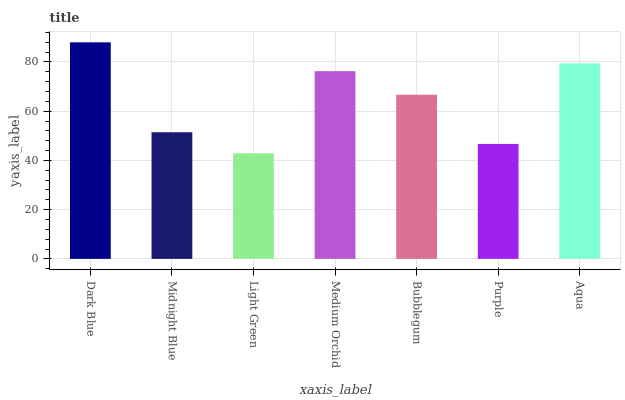Is Midnight Blue the minimum?
Answer yes or no. No. Is Midnight Blue the maximum?
Answer yes or no. No. Is Dark Blue greater than Midnight Blue?
Answer yes or no. Yes. Is Midnight Blue less than Dark Blue?
Answer yes or no. Yes. Is Midnight Blue greater than Dark Blue?
Answer yes or no. No. Is Dark Blue less than Midnight Blue?
Answer yes or no. No. Is Bubblegum the high median?
Answer yes or no. Yes. Is Bubblegum the low median?
Answer yes or no. Yes. Is Purple the high median?
Answer yes or no. No. Is Purple the low median?
Answer yes or no. No. 